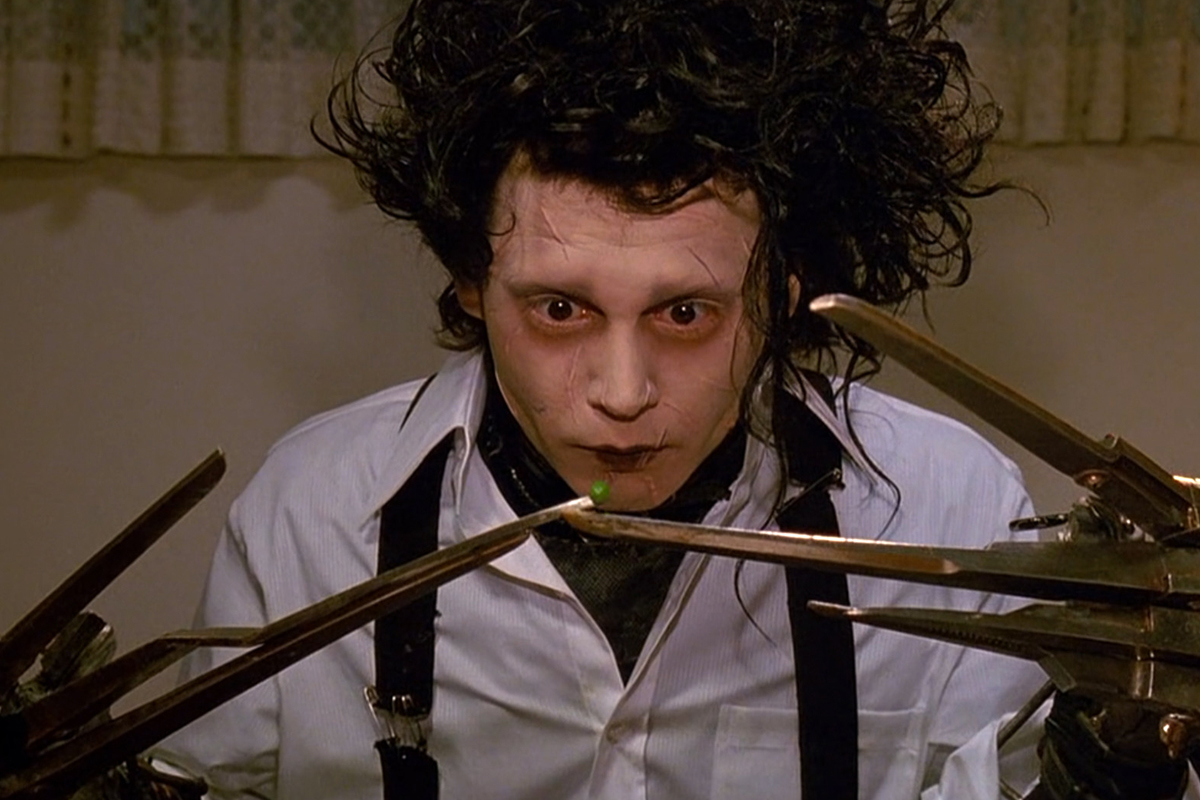What would be the title of this image if it were part of an art exhibition? The Delicate Balance of Isolation Describe how Edward's character might change if he had normal hands instead of scissors. If Edward had normal hands, his character would experience a profound transformation. His ability to perform ordinary tasks without difficulty would likely lead to greater self-confidence and a stronger sense of belonging. Interactions with others would become less fraught with anxiety, allowing him to form deeper connections and integrate more seamlessly into society. However, the loss of his distinctiveness might also diminish some of the poignant aspects of his character, such as his empathy and the unique perspective born from his struggles. The essence of Edward's gentle nature would remain, but his journey would be less about overcoming physical impediments and more about navigating emotional terrain. 